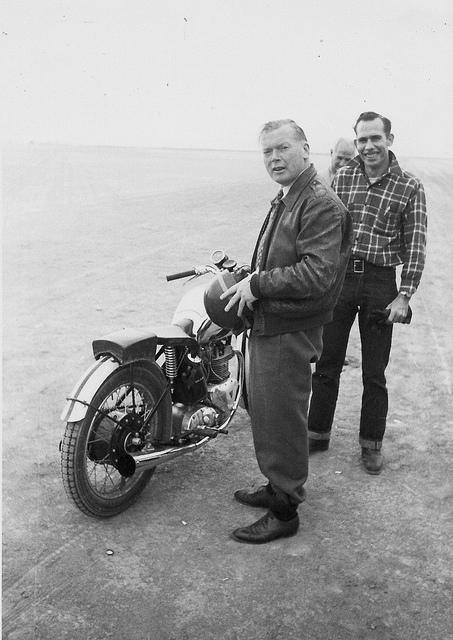Is the biker wearing a leather outfit?
Write a very short answer. No. What make of motorcycle is that?
Keep it brief. Harley. Is this a current photo?
Keep it brief. No. Is the motorcycle fast?
Give a very brief answer. Yes. 